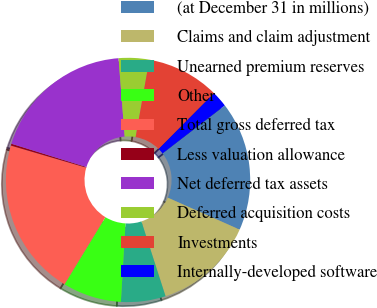<chart> <loc_0><loc_0><loc_500><loc_500><pie_chart><fcel>(at December 31 in millions)<fcel>Claims and claim adjustment<fcel>Unearned premium reserves<fcel>Other<fcel>Total gross deferred tax<fcel>Less valuation allowance<fcel>Net deferred tax assets<fcel>Deferred acquisition costs<fcel>Investments<fcel>Internally-developed software<nl><fcel>17.11%<fcel>13.37%<fcel>5.9%<fcel>7.77%<fcel>20.84%<fcel>0.25%<fcel>18.97%<fcel>4.03%<fcel>9.64%<fcel>2.12%<nl></chart> 